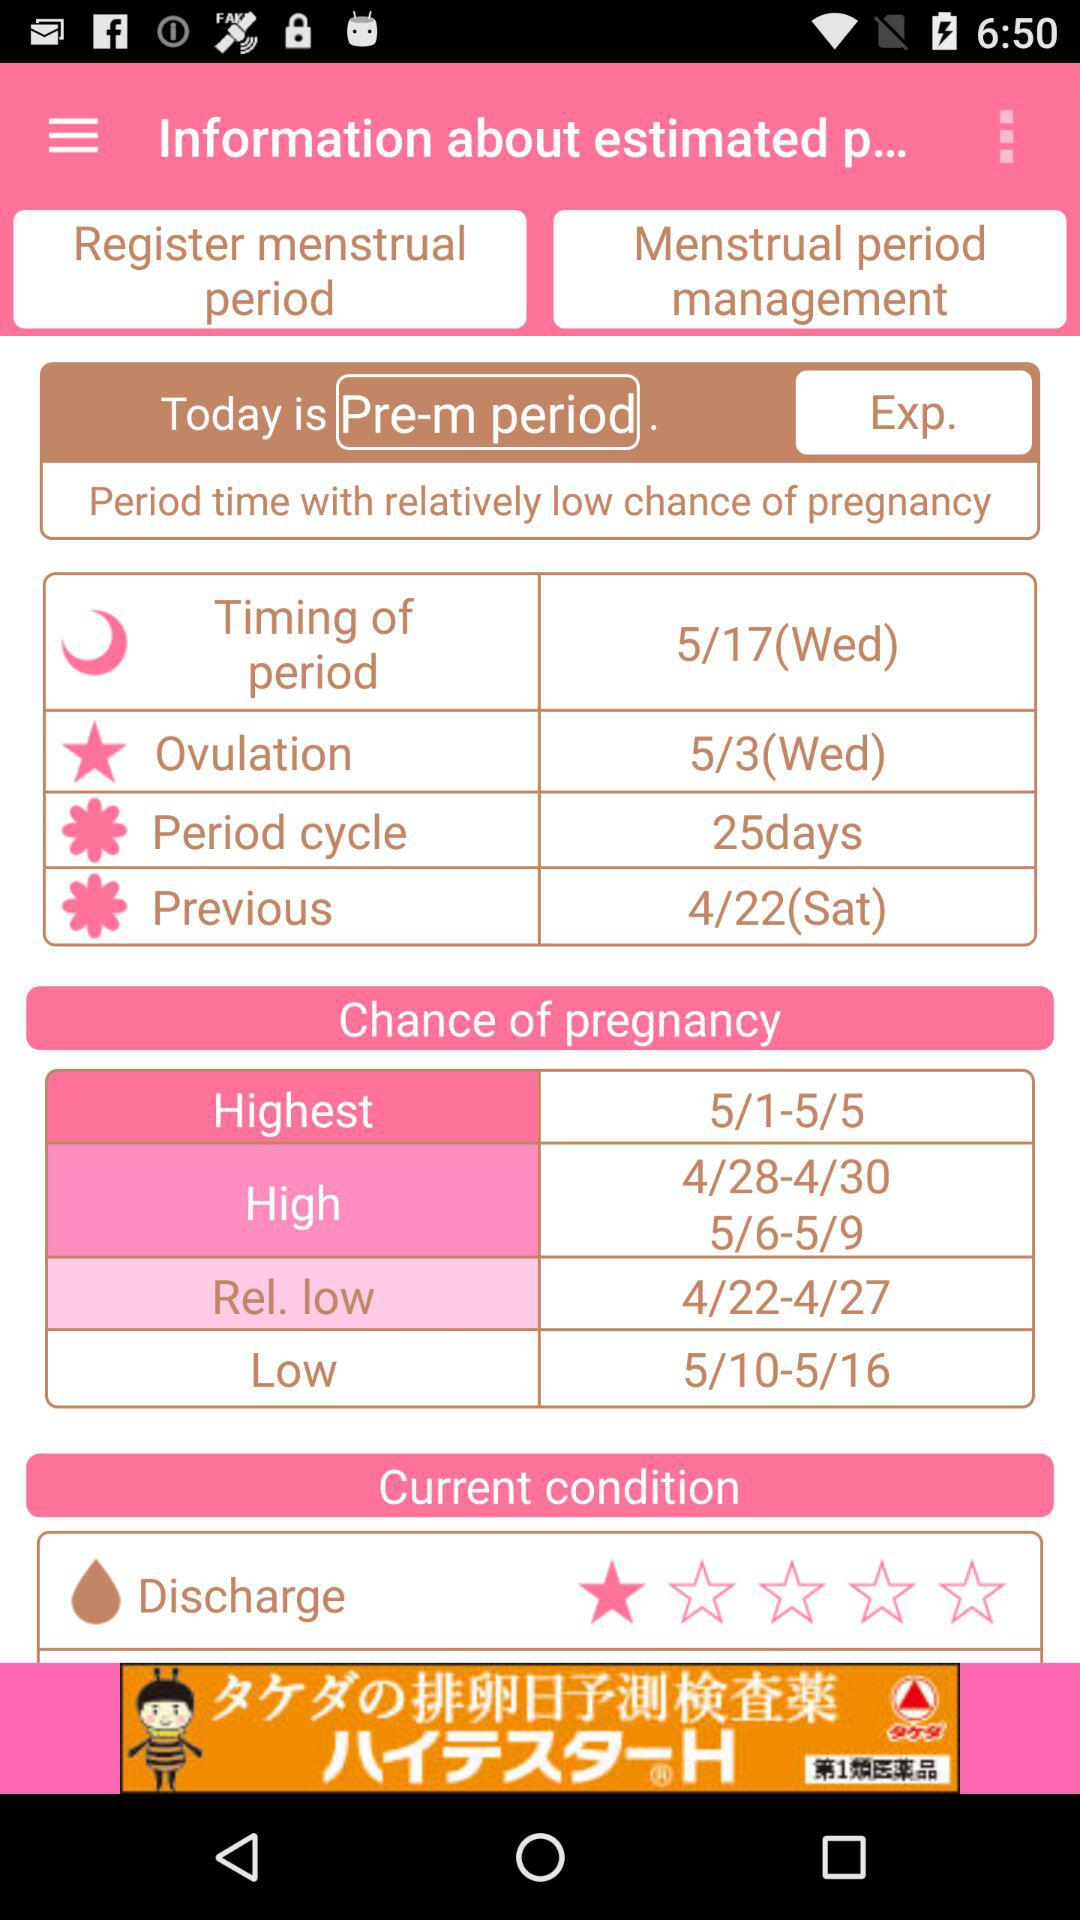On what date is there a chance of a low pregnancy? The dates are 5/10–5/16. 